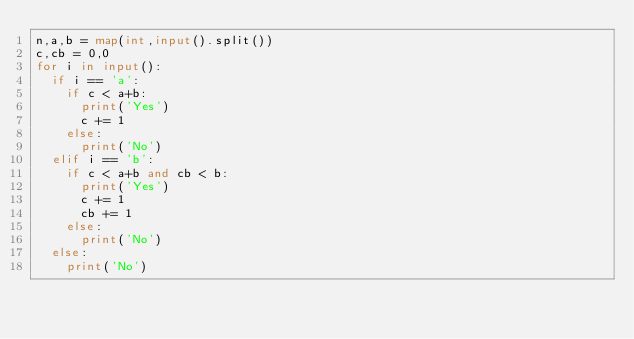Convert code to text. <code><loc_0><loc_0><loc_500><loc_500><_Python_>n,a,b = map(int,input().split())
c,cb = 0,0
for i in input():
  if i == 'a':
    if c < a+b:
      print('Yes')
      c += 1
    else:
      print('No')
  elif i == 'b':
    if c < a+b and cb < b:
      print('Yes')
      c += 1
      cb += 1
    else:
      print('No')
  else:
    print('No')</code> 